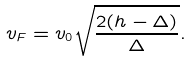<formula> <loc_0><loc_0><loc_500><loc_500>v _ { F } = v _ { 0 } \sqrt { \frac { 2 ( h - \Delta ) } { \Delta } } .</formula> 